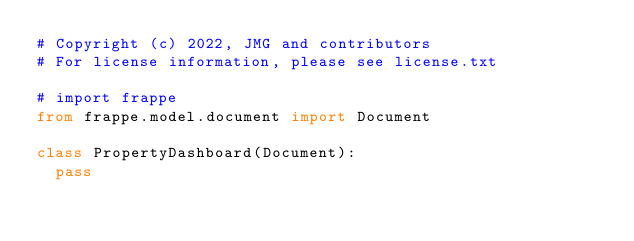<code> <loc_0><loc_0><loc_500><loc_500><_Python_># Copyright (c) 2022, JMG and contributors
# For license information, please see license.txt

# import frappe
from frappe.model.document import Document

class PropertyDashboard(Document):
	pass
</code> 